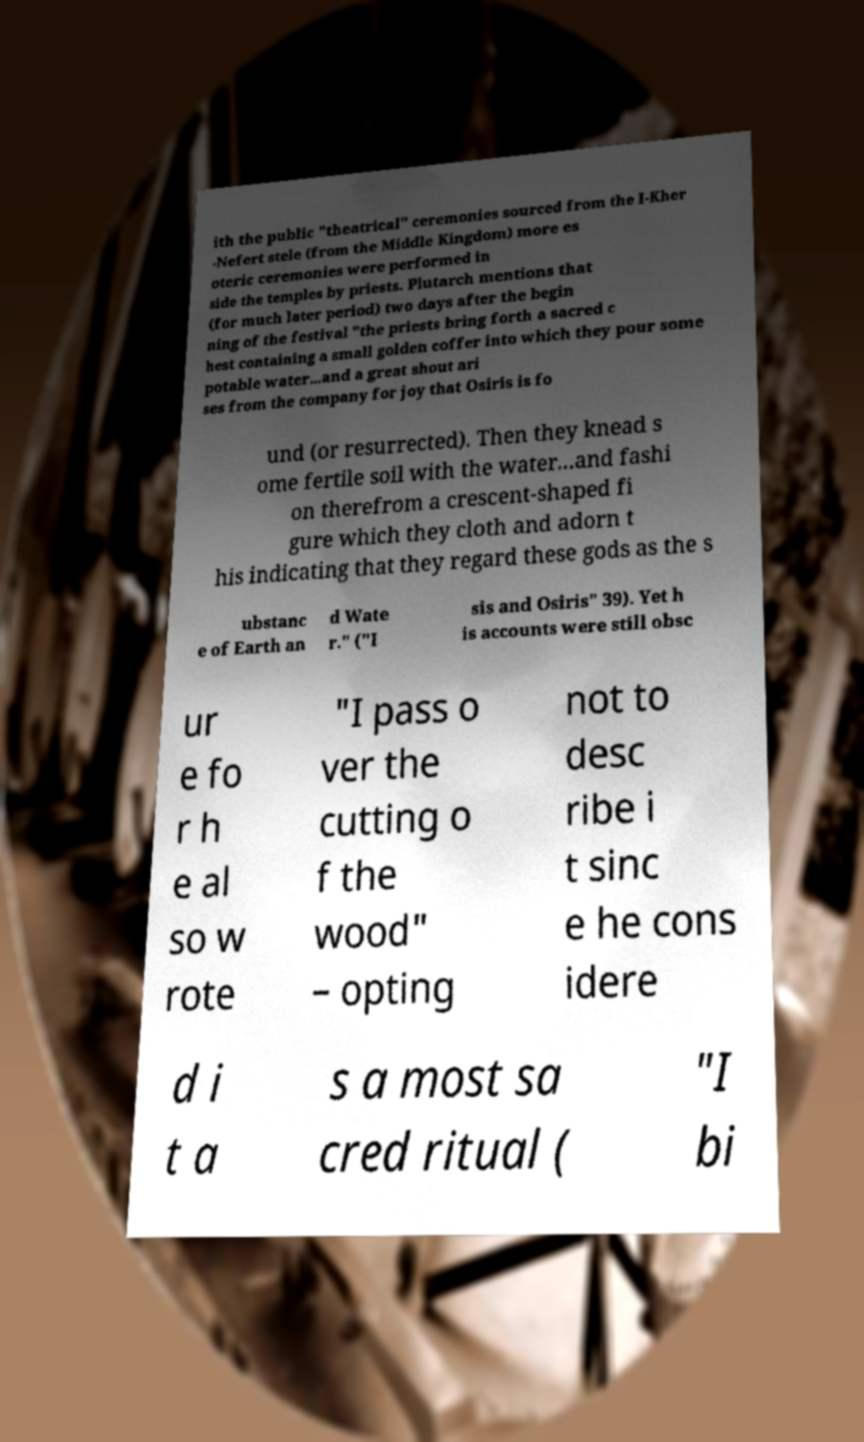For documentation purposes, I need the text within this image transcribed. Could you provide that? ith the public "theatrical" ceremonies sourced from the I-Kher -Nefert stele (from the Middle Kingdom) more es oteric ceremonies were performed in side the temples by priests. Plutarch mentions that (for much later period) two days after the begin ning of the festival "the priests bring forth a sacred c hest containing a small golden coffer into which they pour some potable water...and a great shout ari ses from the company for joy that Osiris is fo und (or resurrected). Then they knead s ome fertile soil with the water...and fashi on therefrom a crescent-shaped fi gure which they cloth and adorn t his indicating that they regard these gods as the s ubstanc e of Earth an d Wate r." ("I sis and Osiris" 39). Yet h is accounts were still obsc ur e fo r h e al so w rote "I pass o ver the cutting o f the wood" – opting not to desc ribe i t sinc e he cons idere d i t a s a most sa cred ritual ( "I bi 